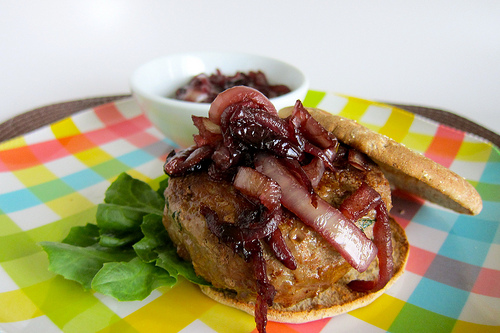<image>
Can you confirm if the lettuce is behind the meat? Yes. From this viewpoint, the lettuce is positioned behind the meat, with the meat partially or fully occluding the lettuce. Is the pizza next to the table? No. The pizza is not positioned next to the table. They are located in different areas of the scene. 